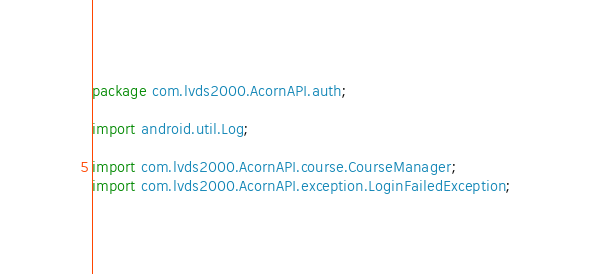Convert code to text. <code><loc_0><loc_0><loc_500><loc_500><_Java_>package com.lvds2000.AcornAPI.auth;

import android.util.Log;

import com.lvds2000.AcornAPI.course.CourseManager;
import com.lvds2000.AcornAPI.exception.LoginFailedException;</code> 